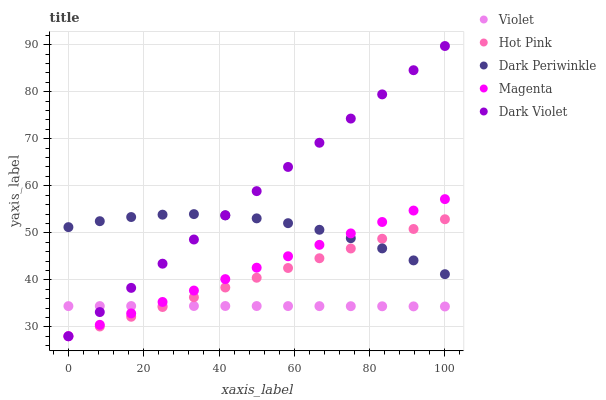Does Violet have the minimum area under the curve?
Answer yes or no. Yes. Does Dark Violet have the maximum area under the curve?
Answer yes or no. Yes. Does Hot Pink have the minimum area under the curve?
Answer yes or no. No. Does Hot Pink have the maximum area under the curve?
Answer yes or no. No. Is Hot Pink the smoothest?
Answer yes or no. Yes. Is Dark Periwinkle the roughest?
Answer yes or no. Yes. Is Dark Periwinkle the smoothest?
Answer yes or no. No. Is Hot Pink the roughest?
Answer yes or no. No. Does Magenta have the lowest value?
Answer yes or no. Yes. Does Dark Periwinkle have the lowest value?
Answer yes or no. No. Does Dark Violet have the highest value?
Answer yes or no. Yes. Does Hot Pink have the highest value?
Answer yes or no. No. Is Violet less than Dark Periwinkle?
Answer yes or no. Yes. Is Dark Periwinkle greater than Violet?
Answer yes or no. Yes. Does Violet intersect Dark Violet?
Answer yes or no. Yes. Is Violet less than Dark Violet?
Answer yes or no. No. Is Violet greater than Dark Violet?
Answer yes or no. No. Does Violet intersect Dark Periwinkle?
Answer yes or no. No. 